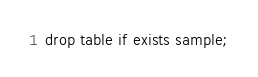Convert code to text. <code><loc_0><loc_0><loc_500><loc_500><_SQL_>drop table if exists sample;
</code> 